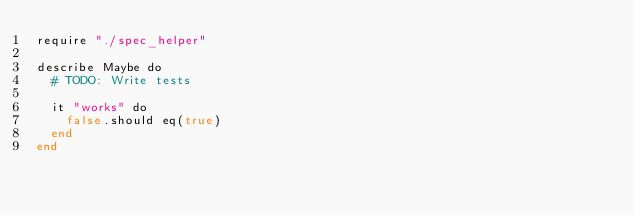<code> <loc_0><loc_0><loc_500><loc_500><_Crystal_>require "./spec_helper"

describe Maybe do
  # TODO: Write tests

  it "works" do
    false.should eq(true)
  end
end
</code> 